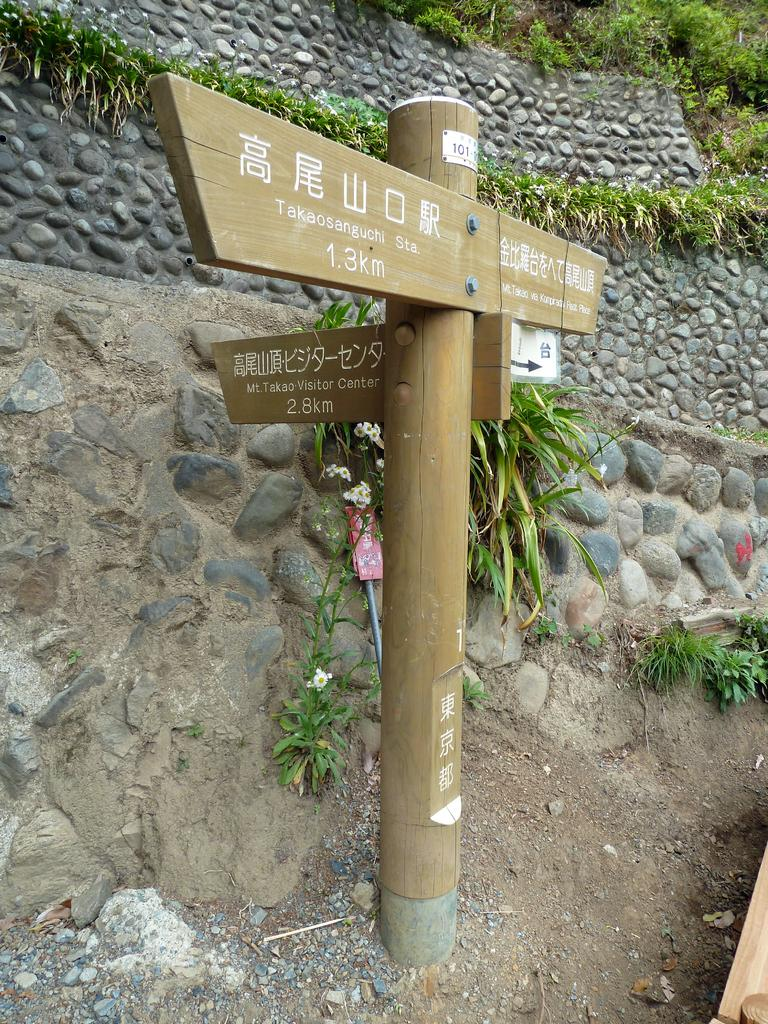What is on the pole in the image? There is a sign board on a pole in the image. What type of vegetation can be seen in the image? There are plants visible in the image. What is the wall in the image made of? The wall in the image is built with stones. Can you see any creatures interacting with the with the plants in the image? There is no creature present in the image; it only features a sign board, plants, and a stone wall. Are there any mountains visible in the image? There are no mountains present in the image. 